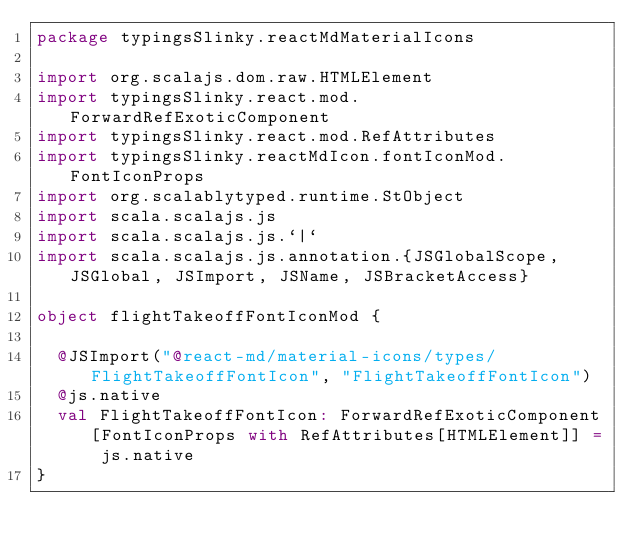Convert code to text. <code><loc_0><loc_0><loc_500><loc_500><_Scala_>package typingsSlinky.reactMdMaterialIcons

import org.scalajs.dom.raw.HTMLElement
import typingsSlinky.react.mod.ForwardRefExoticComponent
import typingsSlinky.react.mod.RefAttributes
import typingsSlinky.reactMdIcon.fontIconMod.FontIconProps
import org.scalablytyped.runtime.StObject
import scala.scalajs.js
import scala.scalajs.js.`|`
import scala.scalajs.js.annotation.{JSGlobalScope, JSGlobal, JSImport, JSName, JSBracketAccess}

object flightTakeoffFontIconMod {
  
  @JSImport("@react-md/material-icons/types/FlightTakeoffFontIcon", "FlightTakeoffFontIcon")
  @js.native
  val FlightTakeoffFontIcon: ForwardRefExoticComponent[FontIconProps with RefAttributes[HTMLElement]] = js.native
}
</code> 